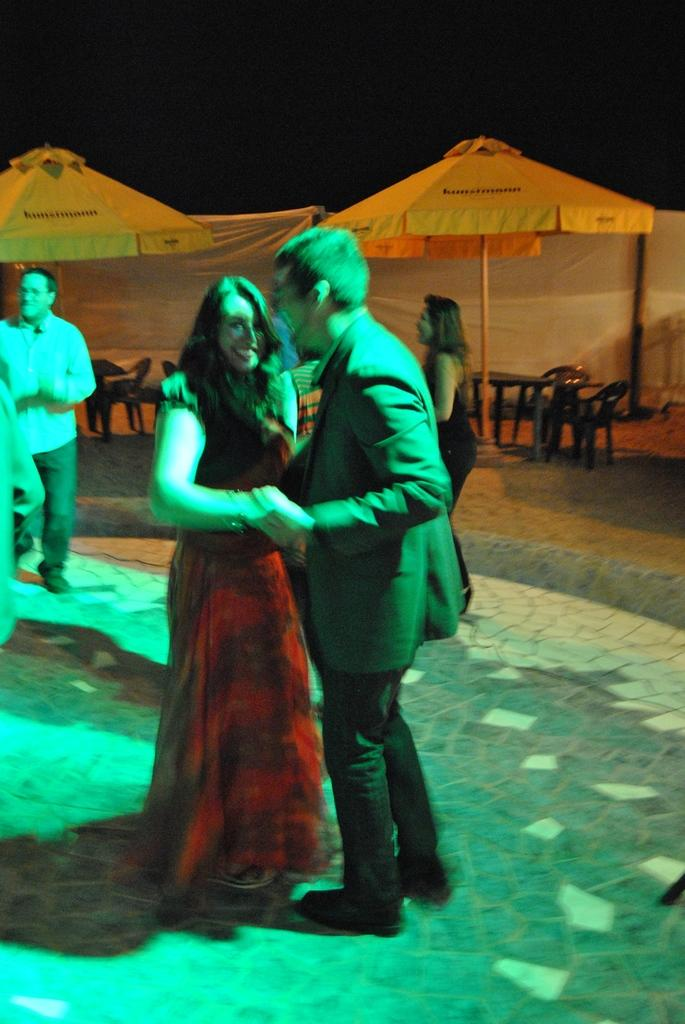What are the main subjects in the image? There is a couple dancing in the image. Can you describe the setting of the image? There are people standing in the background of the image. What objects can be seen in the image besides the dancing couple? There are two umbrellas visible in the image. What type of toy can be seen being cared for by the couple in the image? There is no toy present in the image, and the couple is not caring for any object. 